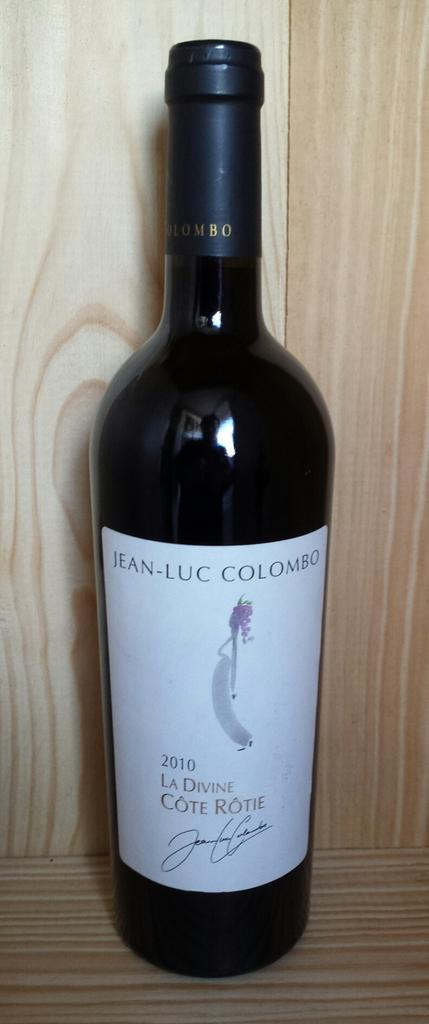<image>
Describe the image concisely. A bottle of Jean-Luc Colombo from 2010 sits on a wood shelf. 